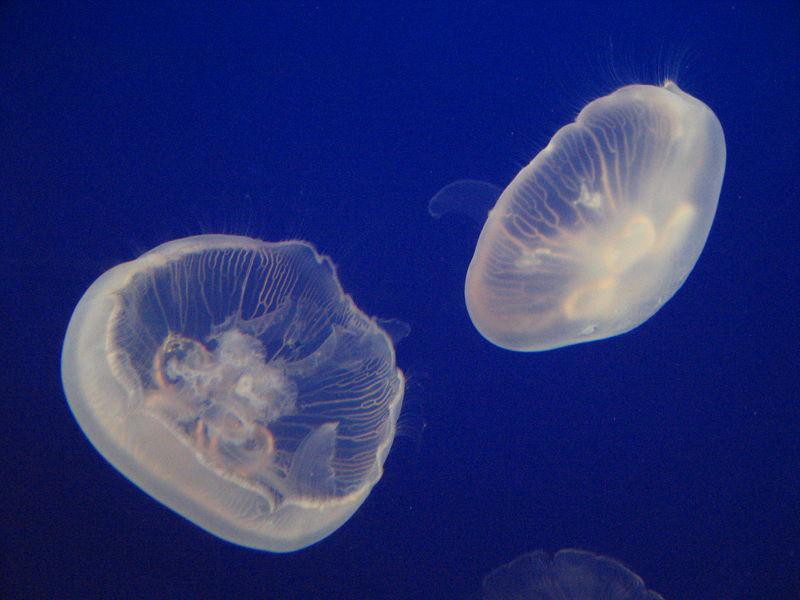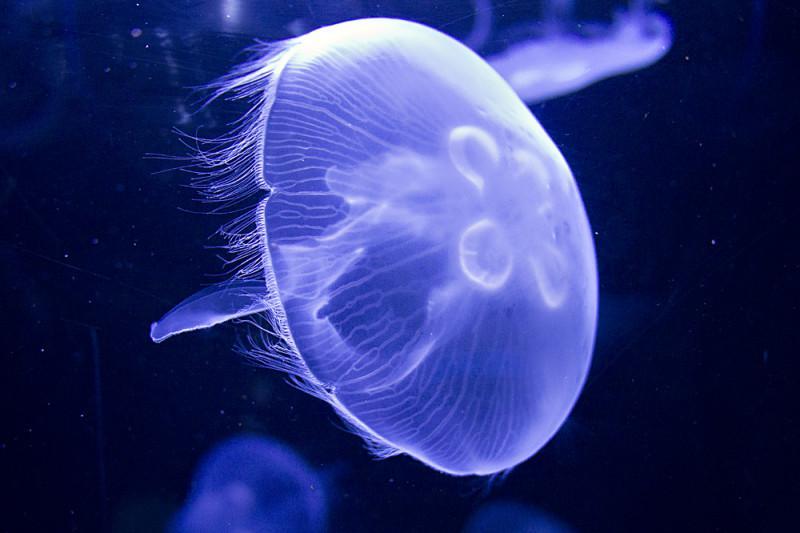The first image is the image on the left, the second image is the image on the right. Considering the images on both sides, is "the right image has a lone jellyfish swimming to the left" valid? Answer yes or no. No. The first image is the image on the left, the second image is the image on the right. Evaluate the accuracy of this statement regarding the images: "There are a total of 2 jelly fish.". Is it true? Answer yes or no. No. 